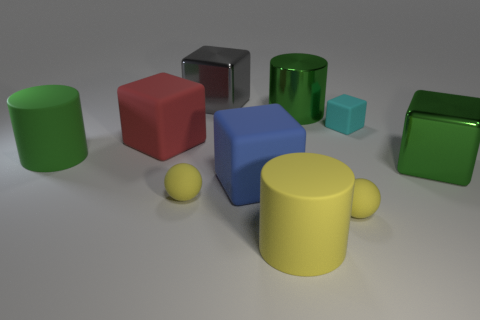Is there a tiny cyan cube that has the same material as the red object?
Offer a very short reply. Yes. What number of spheres are tiny matte things or tiny yellow matte objects?
Ensure brevity in your answer.  2. Are there more small yellow matte objects to the right of the blue matte block than metallic objects to the left of the gray thing?
Give a very brief answer. Yes. How many blocks are the same color as the big shiny cylinder?
Keep it short and to the point. 1. The green object that is the same material as the red block is what size?
Offer a terse response. Large. What number of objects are big things on the left side of the blue object or big red matte cubes?
Provide a short and direct response. 3. There is a large cube to the right of the small cube; is it the same color as the shiny cylinder?
Ensure brevity in your answer.  Yes. What is the size of the green object that is the same shape as the red object?
Give a very brief answer. Large. There is a big cube that is left of the small rubber object that is on the left side of the big matte cylinder right of the red rubber cube; what is its color?
Your answer should be very brief. Red. Is the material of the big green cube the same as the gray block?
Give a very brief answer. Yes. 